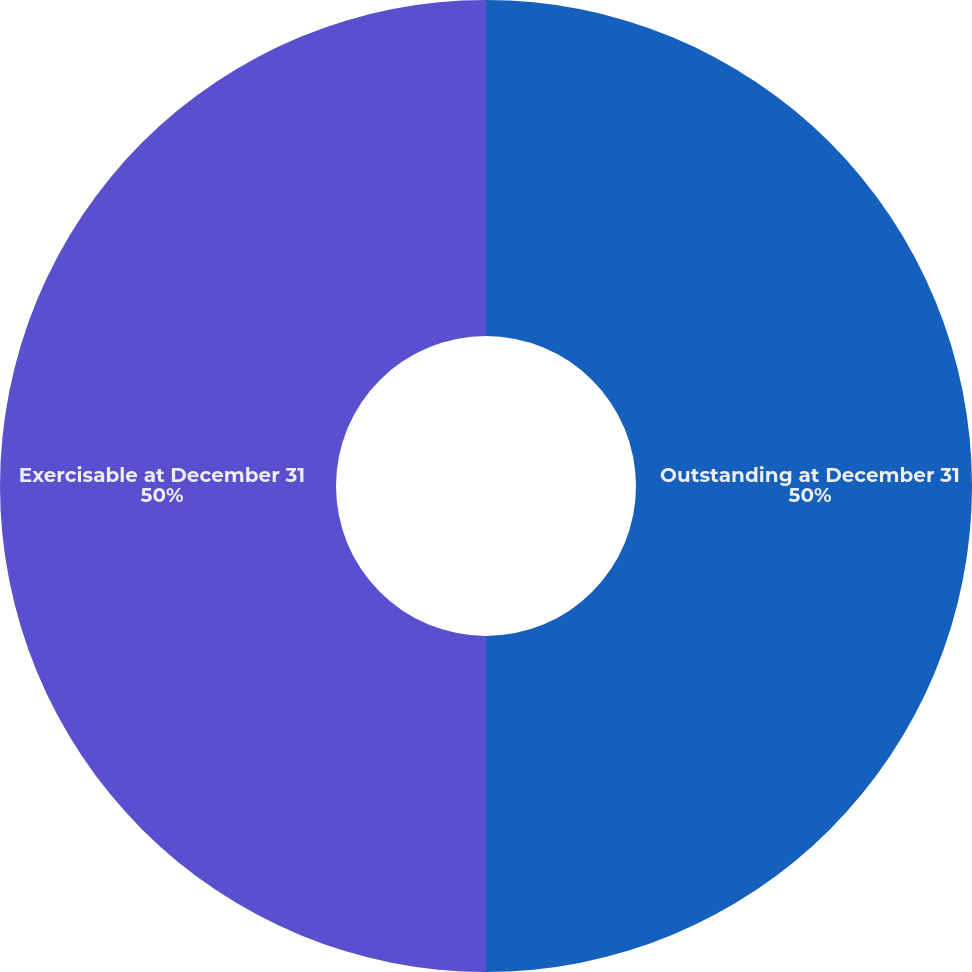Convert chart to OTSL. <chart><loc_0><loc_0><loc_500><loc_500><pie_chart><fcel>Outstanding at December 31<fcel>Exercisable at December 31<nl><fcel>50.0%<fcel>50.0%<nl></chart> 